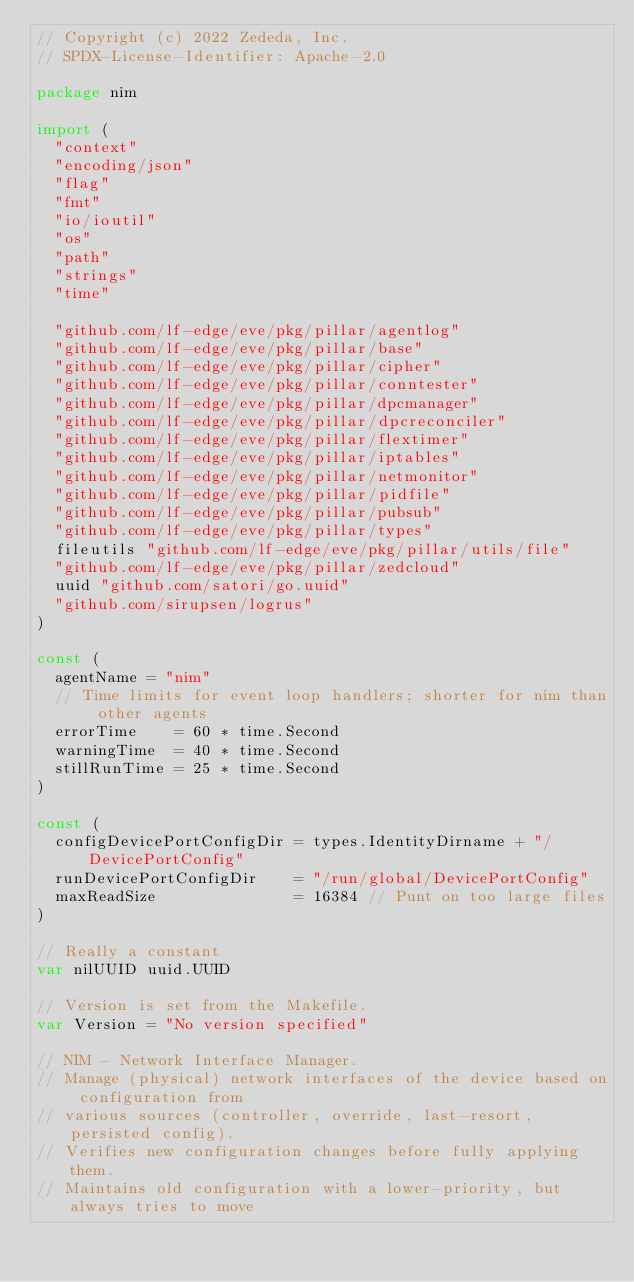Convert code to text. <code><loc_0><loc_0><loc_500><loc_500><_Go_>// Copyright (c) 2022 Zededa, Inc.
// SPDX-License-Identifier: Apache-2.0

package nim

import (
	"context"
	"encoding/json"
	"flag"
	"fmt"
	"io/ioutil"
	"os"
	"path"
	"strings"
	"time"

	"github.com/lf-edge/eve/pkg/pillar/agentlog"
	"github.com/lf-edge/eve/pkg/pillar/base"
	"github.com/lf-edge/eve/pkg/pillar/cipher"
	"github.com/lf-edge/eve/pkg/pillar/conntester"
	"github.com/lf-edge/eve/pkg/pillar/dpcmanager"
	"github.com/lf-edge/eve/pkg/pillar/dpcreconciler"
	"github.com/lf-edge/eve/pkg/pillar/flextimer"
	"github.com/lf-edge/eve/pkg/pillar/iptables"
	"github.com/lf-edge/eve/pkg/pillar/netmonitor"
	"github.com/lf-edge/eve/pkg/pillar/pidfile"
	"github.com/lf-edge/eve/pkg/pillar/pubsub"
	"github.com/lf-edge/eve/pkg/pillar/types"
	fileutils "github.com/lf-edge/eve/pkg/pillar/utils/file"
	"github.com/lf-edge/eve/pkg/pillar/zedcloud"
	uuid "github.com/satori/go.uuid"
	"github.com/sirupsen/logrus"
)

const (
	agentName = "nim"
	// Time limits for event loop handlers; shorter for nim than other agents
	errorTime    = 60 * time.Second
	warningTime  = 40 * time.Second
	stillRunTime = 25 * time.Second
)

const (
	configDevicePortConfigDir = types.IdentityDirname + "/DevicePortConfig"
	runDevicePortConfigDir    = "/run/global/DevicePortConfig"
	maxReadSize               = 16384 // Punt on too large files
)

// Really a constant
var nilUUID uuid.UUID

// Version is set from the Makefile.
var Version = "No version specified"

// NIM - Network Interface Manager.
// Manage (physical) network interfaces of the device based on configuration from
// various sources (controller, override, last-resort, persisted config).
// Verifies new configuration changes before fully applying them.
// Maintains old configuration with a lower-priority, but always tries to move</code> 